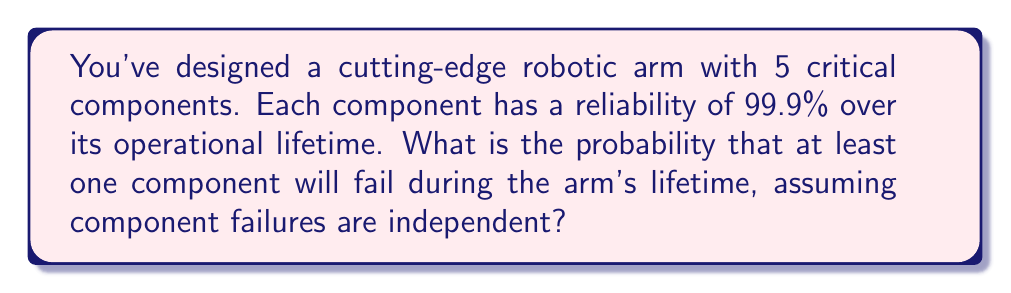Show me your answer to this math problem. Let's approach this step-by-step:

1) First, we need to understand what the question is asking. We're looking for the probability of at least one component failing, which is the opposite of all components working correctly.

2) The probability of a single component working correctly is 0.999 (99.9%).

3) For all components to work correctly, each individual component must work. Since the failures are independent, we multiply the individual probabilities:

   $$P(\text{all working}) = 0.999 * 0.999 * 0.999 * 0.999 * 0.999 = 0.999^5$$

4) We can calculate this:
   $$0.999^5 \approx 0.995005$$

5) This is the probability of all components working. But we want the probability of at least one failing, which is the complement of this probability:

   $$P(\text{at least one failing}) = 1 - P(\text{all working})$$

6) Therefore:
   $$P(\text{at least one failing}) = 1 - 0.995005 = 0.004995$$

7) Converting to a percentage:
   $$0.004995 * 100\% = 0.4995\%$$
Answer: 0.4995% 